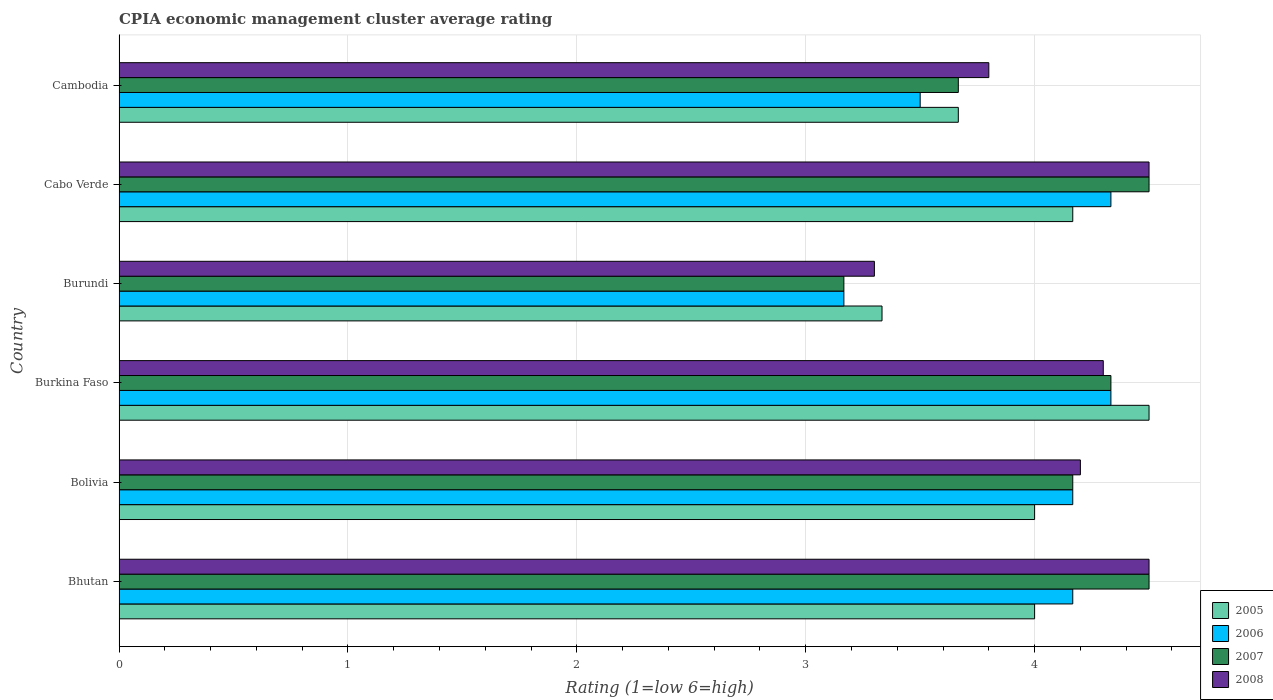How many groups of bars are there?
Offer a terse response. 6. Are the number of bars per tick equal to the number of legend labels?
Keep it short and to the point. Yes. How many bars are there on the 4th tick from the top?
Keep it short and to the point. 4. How many bars are there on the 4th tick from the bottom?
Make the answer very short. 4. What is the label of the 4th group of bars from the top?
Offer a terse response. Burkina Faso. What is the CPIA rating in 2008 in Burkina Faso?
Your response must be concise. 4.3. Across all countries, what is the minimum CPIA rating in 2005?
Your answer should be compact. 3.33. In which country was the CPIA rating in 2007 maximum?
Ensure brevity in your answer.  Bhutan. In which country was the CPIA rating in 2008 minimum?
Keep it short and to the point. Burundi. What is the total CPIA rating in 2005 in the graph?
Your response must be concise. 23.67. What is the difference between the CPIA rating in 2006 in Bolivia and that in Burundi?
Offer a terse response. 1. What is the difference between the CPIA rating in 2008 in Bolivia and the CPIA rating in 2006 in Cambodia?
Your answer should be very brief. 0.7. What is the average CPIA rating in 2005 per country?
Provide a succinct answer. 3.94. What is the difference between the CPIA rating in 2007 and CPIA rating in 2005 in Bolivia?
Offer a terse response. 0.17. What is the ratio of the CPIA rating in 2008 in Bhutan to that in Burkina Faso?
Make the answer very short. 1.05. Is the CPIA rating in 2007 in Burkina Faso less than that in Burundi?
Ensure brevity in your answer.  No. Is the difference between the CPIA rating in 2007 in Bhutan and Cambodia greater than the difference between the CPIA rating in 2005 in Bhutan and Cambodia?
Your answer should be very brief. Yes. What is the difference between the highest and the second highest CPIA rating in 2007?
Make the answer very short. 0. What is the difference between the highest and the lowest CPIA rating in 2005?
Offer a terse response. 1.17. In how many countries, is the CPIA rating in 2005 greater than the average CPIA rating in 2005 taken over all countries?
Give a very brief answer. 4. Is the sum of the CPIA rating in 2006 in Bhutan and Burundi greater than the maximum CPIA rating in 2008 across all countries?
Offer a terse response. Yes. What does the 1st bar from the top in Burkina Faso represents?
Provide a succinct answer. 2008. Is it the case that in every country, the sum of the CPIA rating in 2005 and CPIA rating in 2008 is greater than the CPIA rating in 2006?
Offer a terse response. Yes. Are all the bars in the graph horizontal?
Keep it short and to the point. Yes. Does the graph contain any zero values?
Make the answer very short. No. What is the title of the graph?
Offer a very short reply. CPIA economic management cluster average rating. What is the Rating (1=low 6=high) in 2005 in Bhutan?
Your response must be concise. 4. What is the Rating (1=low 6=high) in 2006 in Bhutan?
Keep it short and to the point. 4.17. What is the Rating (1=low 6=high) of 2005 in Bolivia?
Keep it short and to the point. 4. What is the Rating (1=low 6=high) in 2006 in Bolivia?
Make the answer very short. 4.17. What is the Rating (1=low 6=high) in 2007 in Bolivia?
Offer a very short reply. 4.17. What is the Rating (1=low 6=high) of 2008 in Bolivia?
Ensure brevity in your answer.  4.2. What is the Rating (1=low 6=high) of 2005 in Burkina Faso?
Ensure brevity in your answer.  4.5. What is the Rating (1=low 6=high) in 2006 in Burkina Faso?
Offer a very short reply. 4.33. What is the Rating (1=low 6=high) in 2007 in Burkina Faso?
Your answer should be very brief. 4.33. What is the Rating (1=low 6=high) in 2005 in Burundi?
Your response must be concise. 3.33. What is the Rating (1=low 6=high) of 2006 in Burundi?
Offer a terse response. 3.17. What is the Rating (1=low 6=high) in 2007 in Burundi?
Keep it short and to the point. 3.17. What is the Rating (1=low 6=high) in 2008 in Burundi?
Provide a succinct answer. 3.3. What is the Rating (1=low 6=high) of 2005 in Cabo Verde?
Offer a terse response. 4.17. What is the Rating (1=low 6=high) of 2006 in Cabo Verde?
Ensure brevity in your answer.  4.33. What is the Rating (1=low 6=high) of 2008 in Cabo Verde?
Keep it short and to the point. 4.5. What is the Rating (1=low 6=high) of 2005 in Cambodia?
Your answer should be compact. 3.67. What is the Rating (1=low 6=high) in 2006 in Cambodia?
Ensure brevity in your answer.  3.5. What is the Rating (1=low 6=high) in 2007 in Cambodia?
Your answer should be compact. 3.67. Across all countries, what is the maximum Rating (1=low 6=high) in 2005?
Offer a very short reply. 4.5. Across all countries, what is the maximum Rating (1=low 6=high) in 2006?
Ensure brevity in your answer.  4.33. Across all countries, what is the minimum Rating (1=low 6=high) of 2005?
Provide a succinct answer. 3.33. Across all countries, what is the minimum Rating (1=low 6=high) of 2006?
Make the answer very short. 3.17. Across all countries, what is the minimum Rating (1=low 6=high) in 2007?
Your response must be concise. 3.17. What is the total Rating (1=low 6=high) in 2005 in the graph?
Keep it short and to the point. 23.67. What is the total Rating (1=low 6=high) of 2006 in the graph?
Ensure brevity in your answer.  23.67. What is the total Rating (1=low 6=high) of 2007 in the graph?
Provide a short and direct response. 24.33. What is the total Rating (1=low 6=high) of 2008 in the graph?
Make the answer very short. 24.6. What is the difference between the Rating (1=low 6=high) of 2005 in Bhutan and that in Bolivia?
Your answer should be compact. 0. What is the difference between the Rating (1=low 6=high) in 2007 in Bhutan and that in Bolivia?
Offer a very short reply. 0.33. What is the difference between the Rating (1=low 6=high) of 2005 in Bhutan and that in Burkina Faso?
Give a very brief answer. -0.5. What is the difference between the Rating (1=low 6=high) in 2006 in Bhutan and that in Burkina Faso?
Give a very brief answer. -0.17. What is the difference between the Rating (1=low 6=high) of 2007 in Bhutan and that in Burkina Faso?
Keep it short and to the point. 0.17. What is the difference between the Rating (1=low 6=high) in 2005 in Bhutan and that in Burundi?
Provide a short and direct response. 0.67. What is the difference between the Rating (1=low 6=high) of 2007 in Bhutan and that in Burundi?
Your answer should be compact. 1.33. What is the difference between the Rating (1=low 6=high) of 2008 in Bhutan and that in Burundi?
Your answer should be very brief. 1.2. What is the difference between the Rating (1=low 6=high) of 2005 in Bhutan and that in Cabo Verde?
Keep it short and to the point. -0.17. What is the difference between the Rating (1=low 6=high) of 2006 in Bhutan and that in Cabo Verde?
Give a very brief answer. -0.17. What is the difference between the Rating (1=low 6=high) of 2007 in Bhutan and that in Cabo Verde?
Your answer should be very brief. 0. What is the difference between the Rating (1=low 6=high) of 2005 in Bhutan and that in Cambodia?
Make the answer very short. 0.33. What is the difference between the Rating (1=low 6=high) of 2006 in Bhutan and that in Cambodia?
Offer a very short reply. 0.67. What is the difference between the Rating (1=low 6=high) in 2005 in Bolivia and that in Burkina Faso?
Ensure brevity in your answer.  -0.5. What is the difference between the Rating (1=low 6=high) of 2007 in Bolivia and that in Burkina Faso?
Offer a terse response. -0.17. What is the difference between the Rating (1=low 6=high) of 2005 in Bolivia and that in Cabo Verde?
Offer a terse response. -0.17. What is the difference between the Rating (1=low 6=high) of 2008 in Bolivia and that in Cabo Verde?
Ensure brevity in your answer.  -0.3. What is the difference between the Rating (1=low 6=high) in 2005 in Bolivia and that in Cambodia?
Provide a short and direct response. 0.33. What is the difference between the Rating (1=low 6=high) of 2006 in Bolivia and that in Cambodia?
Ensure brevity in your answer.  0.67. What is the difference between the Rating (1=low 6=high) of 2008 in Bolivia and that in Cambodia?
Your answer should be compact. 0.4. What is the difference between the Rating (1=low 6=high) of 2005 in Burkina Faso and that in Burundi?
Your response must be concise. 1.17. What is the difference between the Rating (1=low 6=high) in 2007 in Burkina Faso and that in Burundi?
Keep it short and to the point. 1.17. What is the difference between the Rating (1=low 6=high) in 2008 in Burkina Faso and that in Burundi?
Your answer should be very brief. 1. What is the difference between the Rating (1=low 6=high) in 2006 in Burkina Faso and that in Cabo Verde?
Keep it short and to the point. 0. What is the difference between the Rating (1=low 6=high) in 2007 in Burkina Faso and that in Cabo Verde?
Your answer should be compact. -0.17. What is the difference between the Rating (1=low 6=high) of 2008 in Burkina Faso and that in Cabo Verde?
Your response must be concise. -0.2. What is the difference between the Rating (1=low 6=high) of 2007 in Burkina Faso and that in Cambodia?
Your answer should be compact. 0.67. What is the difference between the Rating (1=low 6=high) in 2005 in Burundi and that in Cabo Verde?
Offer a very short reply. -0.83. What is the difference between the Rating (1=low 6=high) in 2006 in Burundi and that in Cabo Verde?
Your answer should be compact. -1.17. What is the difference between the Rating (1=low 6=high) of 2007 in Burundi and that in Cabo Verde?
Give a very brief answer. -1.33. What is the difference between the Rating (1=low 6=high) in 2008 in Burundi and that in Cabo Verde?
Make the answer very short. -1.2. What is the difference between the Rating (1=low 6=high) of 2006 in Burundi and that in Cambodia?
Make the answer very short. -0.33. What is the difference between the Rating (1=low 6=high) of 2007 in Burundi and that in Cambodia?
Your response must be concise. -0.5. What is the difference between the Rating (1=low 6=high) in 2008 in Burundi and that in Cambodia?
Provide a succinct answer. -0.5. What is the difference between the Rating (1=low 6=high) in 2005 in Cabo Verde and that in Cambodia?
Your answer should be very brief. 0.5. What is the difference between the Rating (1=low 6=high) in 2006 in Cabo Verde and that in Cambodia?
Provide a short and direct response. 0.83. What is the difference between the Rating (1=low 6=high) of 2008 in Cabo Verde and that in Cambodia?
Give a very brief answer. 0.7. What is the difference between the Rating (1=low 6=high) of 2005 in Bhutan and the Rating (1=low 6=high) of 2006 in Bolivia?
Offer a very short reply. -0.17. What is the difference between the Rating (1=low 6=high) of 2005 in Bhutan and the Rating (1=low 6=high) of 2007 in Bolivia?
Keep it short and to the point. -0.17. What is the difference between the Rating (1=low 6=high) in 2006 in Bhutan and the Rating (1=low 6=high) in 2008 in Bolivia?
Offer a very short reply. -0.03. What is the difference between the Rating (1=low 6=high) of 2007 in Bhutan and the Rating (1=low 6=high) of 2008 in Bolivia?
Provide a short and direct response. 0.3. What is the difference between the Rating (1=low 6=high) of 2005 in Bhutan and the Rating (1=low 6=high) of 2008 in Burkina Faso?
Provide a succinct answer. -0.3. What is the difference between the Rating (1=low 6=high) of 2006 in Bhutan and the Rating (1=low 6=high) of 2008 in Burkina Faso?
Make the answer very short. -0.13. What is the difference between the Rating (1=low 6=high) in 2007 in Bhutan and the Rating (1=low 6=high) in 2008 in Burkina Faso?
Ensure brevity in your answer.  0.2. What is the difference between the Rating (1=low 6=high) in 2005 in Bhutan and the Rating (1=low 6=high) in 2006 in Burundi?
Your answer should be very brief. 0.83. What is the difference between the Rating (1=low 6=high) of 2006 in Bhutan and the Rating (1=low 6=high) of 2008 in Burundi?
Your answer should be very brief. 0.87. What is the difference between the Rating (1=low 6=high) of 2005 in Bhutan and the Rating (1=low 6=high) of 2006 in Cabo Verde?
Your answer should be compact. -0.33. What is the difference between the Rating (1=low 6=high) of 2005 in Bhutan and the Rating (1=low 6=high) of 2008 in Cambodia?
Make the answer very short. 0.2. What is the difference between the Rating (1=low 6=high) of 2006 in Bhutan and the Rating (1=low 6=high) of 2008 in Cambodia?
Ensure brevity in your answer.  0.37. What is the difference between the Rating (1=low 6=high) in 2007 in Bhutan and the Rating (1=low 6=high) in 2008 in Cambodia?
Your response must be concise. 0.7. What is the difference between the Rating (1=low 6=high) in 2005 in Bolivia and the Rating (1=low 6=high) in 2007 in Burkina Faso?
Your answer should be very brief. -0.33. What is the difference between the Rating (1=low 6=high) in 2006 in Bolivia and the Rating (1=low 6=high) in 2008 in Burkina Faso?
Keep it short and to the point. -0.13. What is the difference between the Rating (1=low 6=high) of 2007 in Bolivia and the Rating (1=low 6=high) of 2008 in Burkina Faso?
Offer a terse response. -0.13. What is the difference between the Rating (1=low 6=high) of 2005 in Bolivia and the Rating (1=low 6=high) of 2006 in Burundi?
Your answer should be very brief. 0.83. What is the difference between the Rating (1=low 6=high) of 2006 in Bolivia and the Rating (1=low 6=high) of 2007 in Burundi?
Offer a very short reply. 1. What is the difference between the Rating (1=low 6=high) of 2006 in Bolivia and the Rating (1=low 6=high) of 2008 in Burundi?
Your response must be concise. 0.87. What is the difference between the Rating (1=low 6=high) of 2007 in Bolivia and the Rating (1=low 6=high) of 2008 in Burundi?
Make the answer very short. 0.87. What is the difference between the Rating (1=low 6=high) in 2005 in Bolivia and the Rating (1=low 6=high) in 2006 in Cabo Verde?
Your answer should be compact. -0.33. What is the difference between the Rating (1=low 6=high) of 2005 in Bolivia and the Rating (1=low 6=high) of 2007 in Cabo Verde?
Provide a short and direct response. -0.5. What is the difference between the Rating (1=low 6=high) in 2005 in Bolivia and the Rating (1=low 6=high) in 2008 in Cabo Verde?
Keep it short and to the point. -0.5. What is the difference between the Rating (1=low 6=high) in 2006 in Bolivia and the Rating (1=low 6=high) in 2008 in Cabo Verde?
Provide a short and direct response. -0.33. What is the difference between the Rating (1=low 6=high) of 2007 in Bolivia and the Rating (1=low 6=high) of 2008 in Cabo Verde?
Ensure brevity in your answer.  -0.33. What is the difference between the Rating (1=low 6=high) of 2005 in Bolivia and the Rating (1=low 6=high) of 2007 in Cambodia?
Offer a very short reply. 0.33. What is the difference between the Rating (1=low 6=high) of 2005 in Bolivia and the Rating (1=low 6=high) of 2008 in Cambodia?
Your answer should be compact. 0.2. What is the difference between the Rating (1=low 6=high) in 2006 in Bolivia and the Rating (1=low 6=high) in 2007 in Cambodia?
Your answer should be compact. 0.5. What is the difference between the Rating (1=low 6=high) in 2006 in Bolivia and the Rating (1=low 6=high) in 2008 in Cambodia?
Make the answer very short. 0.37. What is the difference between the Rating (1=low 6=high) of 2007 in Bolivia and the Rating (1=low 6=high) of 2008 in Cambodia?
Provide a succinct answer. 0.37. What is the difference between the Rating (1=low 6=high) in 2005 in Burkina Faso and the Rating (1=low 6=high) in 2006 in Burundi?
Provide a short and direct response. 1.33. What is the difference between the Rating (1=low 6=high) in 2005 in Burkina Faso and the Rating (1=low 6=high) in 2007 in Burundi?
Provide a short and direct response. 1.33. What is the difference between the Rating (1=low 6=high) of 2005 in Burkina Faso and the Rating (1=low 6=high) of 2008 in Burundi?
Ensure brevity in your answer.  1.2. What is the difference between the Rating (1=low 6=high) of 2006 in Burkina Faso and the Rating (1=low 6=high) of 2008 in Burundi?
Provide a succinct answer. 1.03. What is the difference between the Rating (1=low 6=high) of 2007 in Burkina Faso and the Rating (1=low 6=high) of 2008 in Burundi?
Your answer should be compact. 1.03. What is the difference between the Rating (1=low 6=high) in 2005 in Burkina Faso and the Rating (1=low 6=high) in 2006 in Cabo Verde?
Give a very brief answer. 0.17. What is the difference between the Rating (1=low 6=high) in 2006 in Burkina Faso and the Rating (1=low 6=high) in 2007 in Cabo Verde?
Provide a short and direct response. -0.17. What is the difference between the Rating (1=low 6=high) of 2007 in Burkina Faso and the Rating (1=low 6=high) of 2008 in Cabo Verde?
Provide a succinct answer. -0.17. What is the difference between the Rating (1=low 6=high) in 2005 in Burkina Faso and the Rating (1=low 6=high) in 2008 in Cambodia?
Your response must be concise. 0.7. What is the difference between the Rating (1=low 6=high) in 2006 in Burkina Faso and the Rating (1=low 6=high) in 2008 in Cambodia?
Offer a very short reply. 0.53. What is the difference between the Rating (1=low 6=high) of 2007 in Burkina Faso and the Rating (1=low 6=high) of 2008 in Cambodia?
Offer a terse response. 0.53. What is the difference between the Rating (1=low 6=high) in 2005 in Burundi and the Rating (1=low 6=high) in 2006 in Cabo Verde?
Your answer should be very brief. -1. What is the difference between the Rating (1=low 6=high) of 2005 in Burundi and the Rating (1=low 6=high) of 2007 in Cabo Verde?
Your answer should be very brief. -1.17. What is the difference between the Rating (1=low 6=high) in 2005 in Burundi and the Rating (1=low 6=high) in 2008 in Cabo Verde?
Ensure brevity in your answer.  -1.17. What is the difference between the Rating (1=low 6=high) of 2006 in Burundi and the Rating (1=low 6=high) of 2007 in Cabo Verde?
Offer a terse response. -1.33. What is the difference between the Rating (1=low 6=high) in 2006 in Burundi and the Rating (1=low 6=high) in 2008 in Cabo Verde?
Give a very brief answer. -1.33. What is the difference between the Rating (1=low 6=high) of 2007 in Burundi and the Rating (1=low 6=high) of 2008 in Cabo Verde?
Make the answer very short. -1.33. What is the difference between the Rating (1=low 6=high) of 2005 in Burundi and the Rating (1=low 6=high) of 2006 in Cambodia?
Your response must be concise. -0.17. What is the difference between the Rating (1=low 6=high) in 2005 in Burundi and the Rating (1=low 6=high) in 2007 in Cambodia?
Offer a terse response. -0.33. What is the difference between the Rating (1=low 6=high) in 2005 in Burundi and the Rating (1=low 6=high) in 2008 in Cambodia?
Your answer should be very brief. -0.47. What is the difference between the Rating (1=low 6=high) in 2006 in Burundi and the Rating (1=low 6=high) in 2007 in Cambodia?
Your answer should be very brief. -0.5. What is the difference between the Rating (1=low 6=high) in 2006 in Burundi and the Rating (1=low 6=high) in 2008 in Cambodia?
Provide a short and direct response. -0.63. What is the difference between the Rating (1=low 6=high) in 2007 in Burundi and the Rating (1=low 6=high) in 2008 in Cambodia?
Provide a succinct answer. -0.63. What is the difference between the Rating (1=low 6=high) in 2005 in Cabo Verde and the Rating (1=low 6=high) in 2008 in Cambodia?
Offer a very short reply. 0.37. What is the difference between the Rating (1=low 6=high) of 2006 in Cabo Verde and the Rating (1=low 6=high) of 2008 in Cambodia?
Give a very brief answer. 0.53. What is the average Rating (1=low 6=high) of 2005 per country?
Make the answer very short. 3.94. What is the average Rating (1=low 6=high) in 2006 per country?
Ensure brevity in your answer.  3.94. What is the average Rating (1=low 6=high) in 2007 per country?
Ensure brevity in your answer.  4.06. What is the average Rating (1=low 6=high) of 2008 per country?
Ensure brevity in your answer.  4.1. What is the difference between the Rating (1=low 6=high) in 2005 and Rating (1=low 6=high) in 2008 in Bhutan?
Provide a short and direct response. -0.5. What is the difference between the Rating (1=low 6=high) in 2006 and Rating (1=low 6=high) in 2007 in Bhutan?
Provide a succinct answer. -0.33. What is the difference between the Rating (1=low 6=high) of 2006 and Rating (1=low 6=high) of 2008 in Bhutan?
Make the answer very short. -0.33. What is the difference between the Rating (1=low 6=high) in 2005 and Rating (1=low 6=high) in 2006 in Bolivia?
Make the answer very short. -0.17. What is the difference between the Rating (1=low 6=high) of 2005 and Rating (1=low 6=high) of 2008 in Bolivia?
Your answer should be compact. -0.2. What is the difference between the Rating (1=low 6=high) in 2006 and Rating (1=low 6=high) in 2007 in Bolivia?
Offer a very short reply. 0. What is the difference between the Rating (1=low 6=high) of 2006 and Rating (1=low 6=high) of 2008 in Bolivia?
Keep it short and to the point. -0.03. What is the difference between the Rating (1=low 6=high) of 2007 and Rating (1=low 6=high) of 2008 in Bolivia?
Your response must be concise. -0.03. What is the difference between the Rating (1=low 6=high) in 2005 and Rating (1=low 6=high) in 2007 in Burkina Faso?
Offer a terse response. 0.17. What is the difference between the Rating (1=low 6=high) of 2006 and Rating (1=low 6=high) of 2008 in Burkina Faso?
Provide a succinct answer. 0.03. What is the difference between the Rating (1=low 6=high) in 2005 and Rating (1=low 6=high) in 2006 in Burundi?
Ensure brevity in your answer.  0.17. What is the difference between the Rating (1=low 6=high) of 2005 and Rating (1=low 6=high) of 2007 in Burundi?
Provide a short and direct response. 0.17. What is the difference between the Rating (1=low 6=high) in 2006 and Rating (1=low 6=high) in 2007 in Burundi?
Provide a short and direct response. 0. What is the difference between the Rating (1=low 6=high) in 2006 and Rating (1=low 6=high) in 2008 in Burundi?
Ensure brevity in your answer.  -0.13. What is the difference between the Rating (1=low 6=high) of 2007 and Rating (1=low 6=high) of 2008 in Burundi?
Ensure brevity in your answer.  -0.13. What is the difference between the Rating (1=low 6=high) of 2006 and Rating (1=low 6=high) of 2008 in Cabo Verde?
Your answer should be compact. -0.17. What is the difference between the Rating (1=low 6=high) of 2007 and Rating (1=low 6=high) of 2008 in Cabo Verde?
Your response must be concise. 0. What is the difference between the Rating (1=low 6=high) of 2005 and Rating (1=low 6=high) of 2006 in Cambodia?
Your answer should be very brief. 0.17. What is the difference between the Rating (1=low 6=high) of 2005 and Rating (1=low 6=high) of 2008 in Cambodia?
Your answer should be compact. -0.13. What is the difference between the Rating (1=low 6=high) in 2006 and Rating (1=low 6=high) in 2008 in Cambodia?
Provide a succinct answer. -0.3. What is the difference between the Rating (1=low 6=high) in 2007 and Rating (1=low 6=high) in 2008 in Cambodia?
Your answer should be very brief. -0.13. What is the ratio of the Rating (1=low 6=high) in 2005 in Bhutan to that in Bolivia?
Your answer should be very brief. 1. What is the ratio of the Rating (1=low 6=high) in 2008 in Bhutan to that in Bolivia?
Give a very brief answer. 1.07. What is the ratio of the Rating (1=low 6=high) of 2006 in Bhutan to that in Burkina Faso?
Offer a terse response. 0.96. What is the ratio of the Rating (1=low 6=high) in 2008 in Bhutan to that in Burkina Faso?
Offer a terse response. 1.05. What is the ratio of the Rating (1=low 6=high) in 2005 in Bhutan to that in Burundi?
Give a very brief answer. 1.2. What is the ratio of the Rating (1=low 6=high) of 2006 in Bhutan to that in Burundi?
Ensure brevity in your answer.  1.32. What is the ratio of the Rating (1=low 6=high) in 2007 in Bhutan to that in Burundi?
Your answer should be compact. 1.42. What is the ratio of the Rating (1=low 6=high) of 2008 in Bhutan to that in Burundi?
Provide a succinct answer. 1.36. What is the ratio of the Rating (1=low 6=high) in 2006 in Bhutan to that in Cabo Verde?
Make the answer very short. 0.96. What is the ratio of the Rating (1=low 6=high) of 2007 in Bhutan to that in Cabo Verde?
Offer a very short reply. 1. What is the ratio of the Rating (1=low 6=high) of 2006 in Bhutan to that in Cambodia?
Offer a terse response. 1.19. What is the ratio of the Rating (1=low 6=high) of 2007 in Bhutan to that in Cambodia?
Give a very brief answer. 1.23. What is the ratio of the Rating (1=low 6=high) in 2008 in Bhutan to that in Cambodia?
Ensure brevity in your answer.  1.18. What is the ratio of the Rating (1=low 6=high) of 2006 in Bolivia to that in Burkina Faso?
Provide a succinct answer. 0.96. What is the ratio of the Rating (1=low 6=high) in 2007 in Bolivia to that in Burkina Faso?
Your answer should be compact. 0.96. What is the ratio of the Rating (1=low 6=high) in 2008 in Bolivia to that in Burkina Faso?
Keep it short and to the point. 0.98. What is the ratio of the Rating (1=low 6=high) of 2005 in Bolivia to that in Burundi?
Offer a terse response. 1.2. What is the ratio of the Rating (1=low 6=high) in 2006 in Bolivia to that in Burundi?
Ensure brevity in your answer.  1.32. What is the ratio of the Rating (1=low 6=high) in 2007 in Bolivia to that in Burundi?
Provide a short and direct response. 1.32. What is the ratio of the Rating (1=low 6=high) in 2008 in Bolivia to that in Burundi?
Keep it short and to the point. 1.27. What is the ratio of the Rating (1=low 6=high) in 2005 in Bolivia to that in Cabo Verde?
Offer a very short reply. 0.96. What is the ratio of the Rating (1=low 6=high) of 2006 in Bolivia to that in Cabo Verde?
Ensure brevity in your answer.  0.96. What is the ratio of the Rating (1=low 6=high) in 2007 in Bolivia to that in Cabo Verde?
Ensure brevity in your answer.  0.93. What is the ratio of the Rating (1=low 6=high) of 2008 in Bolivia to that in Cabo Verde?
Your answer should be very brief. 0.93. What is the ratio of the Rating (1=low 6=high) of 2006 in Bolivia to that in Cambodia?
Make the answer very short. 1.19. What is the ratio of the Rating (1=low 6=high) of 2007 in Bolivia to that in Cambodia?
Your response must be concise. 1.14. What is the ratio of the Rating (1=low 6=high) of 2008 in Bolivia to that in Cambodia?
Offer a very short reply. 1.11. What is the ratio of the Rating (1=low 6=high) in 2005 in Burkina Faso to that in Burundi?
Your answer should be compact. 1.35. What is the ratio of the Rating (1=low 6=high) of 2006 in Burkina Faso to that in Burundi?
Provide a succinct answer. 1.37. What is the ratio of the Rating (1=low 6=high) in 2007 in Burkina Faso to that in Burundi?
Your answer should be compact. 1.37. What is the ratio of the Rating (1=low 6=high) in 2008 in Burkina Faso to that in Burundi?
Your answer should be very brief. 1.3. What is the ratio of the Rating (1=low 6=high) of 2005 in Burkina Faso to that in Cabo Verde?
Your answer should be very brief. 1.08. What is the ratio of the Rating (1=low 6=high) in 2008 in Burkina Faso to that in Cabo Verde?
Keep it short and to the point. 0.96. What is the ratio of the Rating (1=low 6=high) in 2005 in Burkina Faso to that in Cambodia?
Ensure brevity in your answer.  1.23. What is the ratio of the Rating (1=low 6=high) of 2006 in Burkina Faso to that in Cambodia?
Offer a terse response. 1.24. What is the ratio of the Rating (1=low 6=high) of 2007 in Burkina Faso to that in Cambodia?
Offer a terse response. 1.18. What is the ratio of the Rating (1=low 6=high) of 2008 in Burkina Faso to that in Cambodia?
Provide a succinct answer. 1.13. What is the ratio of the Rating (1=low 6=high) in 2005 in Burundi to that in Cabo Verde?
Keep it short and to the point. 0.8. What is the ratio of the Rating (1=low 6=high) of 2006 in Burundi to that in Cabo Verde?
Your answer should be very brief. 0.73. What is the ratio of the Rating (1=low 6=high) of 2007 in Burundi to that in Cabo Verde?
Offer a terse response. 0.7. What is the ratio of the Rating (1=low 6=high) of 2008 in Burundi to that in Cabo Verde?
Your response must be concise. 0.73. What is the ratio of the Rating (1=low 6=high) of 2006 in Burundi to that in Cambodia?
Ensure brevity in your answer.  0.9. What is the ratio of the Rating (1=low 6=high) in 2007 in Burundi to that in Cambodia?
Provide a succinct answer. 0.86. What is the ratio of the Rating (1=low 6=high) of 2008 in Burundi to that in Cambodia?
Make the answer very short. 0.87. What is the ratio of the Rating (1=low 6=high) in 2005 in Cabo Verde to that in Cambodia?
Offer a very short reply. 1.14. What is the ratio of the Rating (1=low 6=high) in 2006 in Cabo Verde to that in Cambodia?
Make the answer very short. 1.24. What is the ratio of the Rating (1=low 6=high) in 2007 in Cabo Verde to that in Cambodia?
Your answer should be very brief. 1.23. What is the ratio of the Rating (1=low 6=high) in 2008 in Cabo Verde to that in Cambodia?
Give a very brief answer. 1.18. What is the difference between the highest and the lowest Rating (1=low 6=high) of 2006?
Make the answer very short. 1.17. What is the difference between the highest and the lowest Rating (1=low 6=high) of 2007?
Offer a terse response. 1.33. 